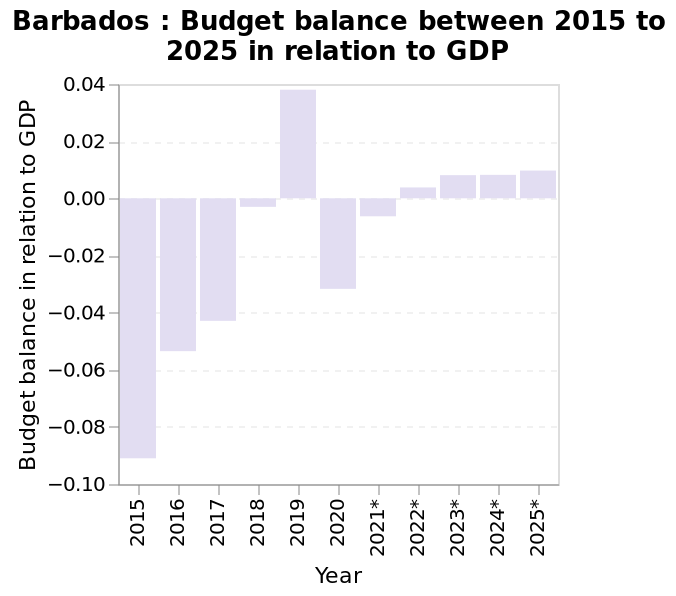<image>
What was the forecast for the trend of the balance budget? The forecast was for the trend of the balance budget to bounce back and then keep improving. 